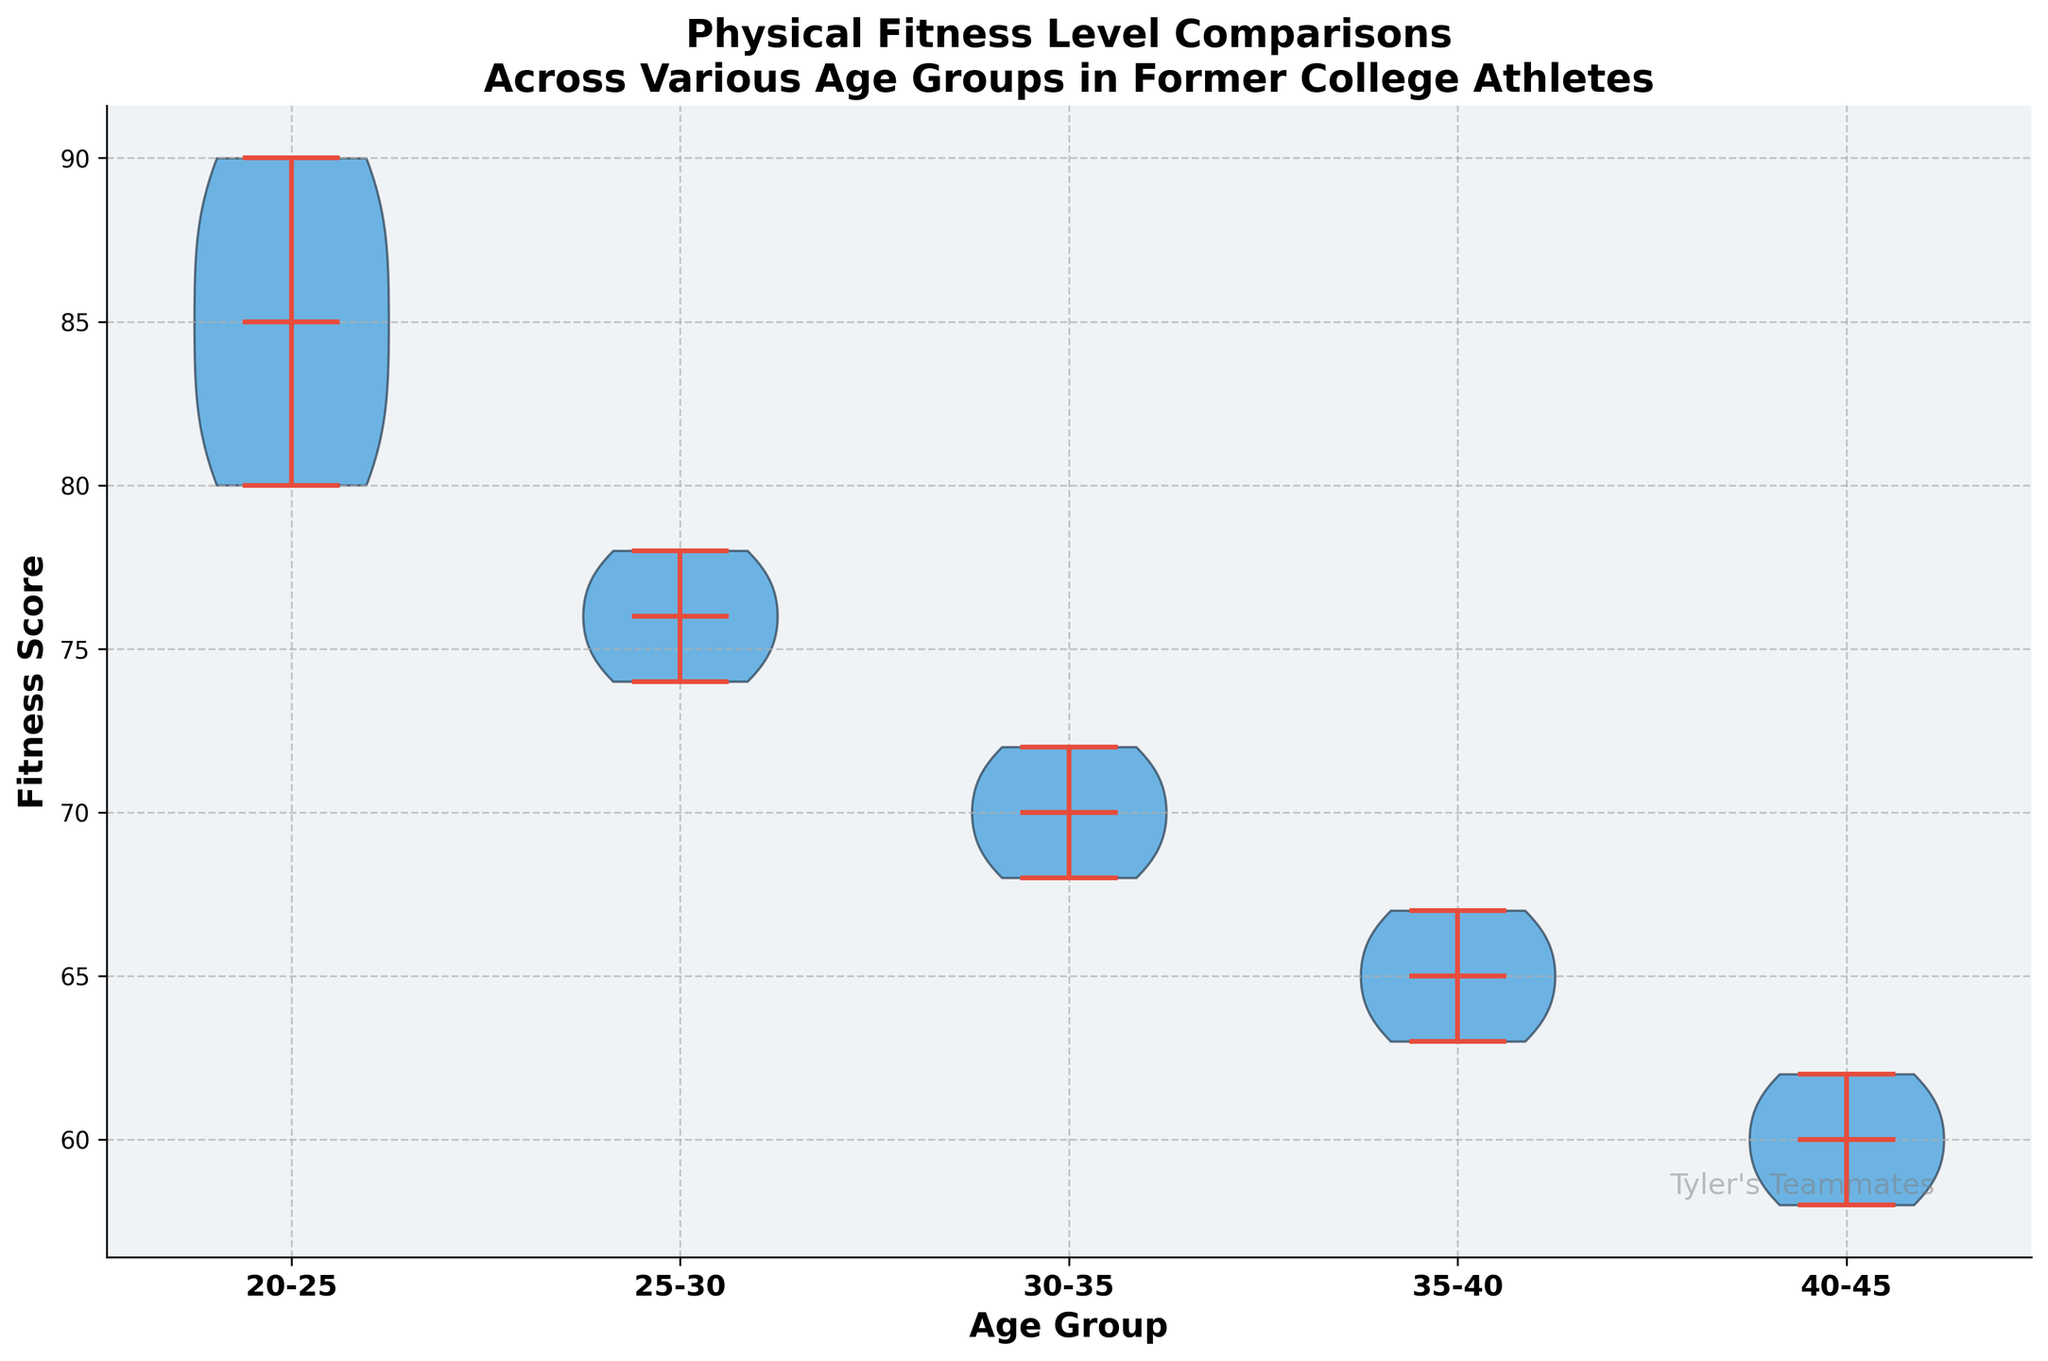What's the title of the figure? The title of the figure is displayed at the top of the chart, describing the overall purpose and focus.
Answer: Physical Fitness Level Comparisons Across Various Age Groups in Former College Athletes How many age groups are included in the plot? By looking at the x-axis labels, we can count the distinct age groups represented on the chart.
Answer: 5 Which age group has the highest median fitness score? We examine the horizontal line within each violin plot that represents the median value. The group with the highest horizontal line has the highest median.
Answer: 20-25 What is the range of fitness scores for the 30-35 age group? The range is determined by looking at the minimum and maximum points of the 'violin' for the 30-35 age group on the y-axis.
Answer: 68-72 Which age group shows the largest variability in fitness scores? Variability can be assessed by examining the width and spread of each violin plot. The group with the widest and most spread out violin indicates larger variability.
Answer: 20-25 What is the overall trend in median fitness scores as age increases? By observing the median lines across the age groups, we can see how the values change as age increases.
Answer: Decreasing What are the mean fitness scores for the 25-30 and 35-40 age groups? The mean score is indicated by a distinct mark within each violin plot. We check these marks for the 25-30 and 35-40 age groups to determine their mean values.
Answer: 25-30: 76, 35-40: 65 Comparing the extremes, which age group has the highest maximum fitness score and which has the lowest minimum? We look for the topmost point of the 'violin' for the highest and the bottommost point for the lowest across all age groups.
Answer: Highest: 20-25, Lowest: 40-45 What does the custom watermark say? The watermark is a text displayed on the plot, often for branding or identification purposes.
Answer: Tyler's Teammates 